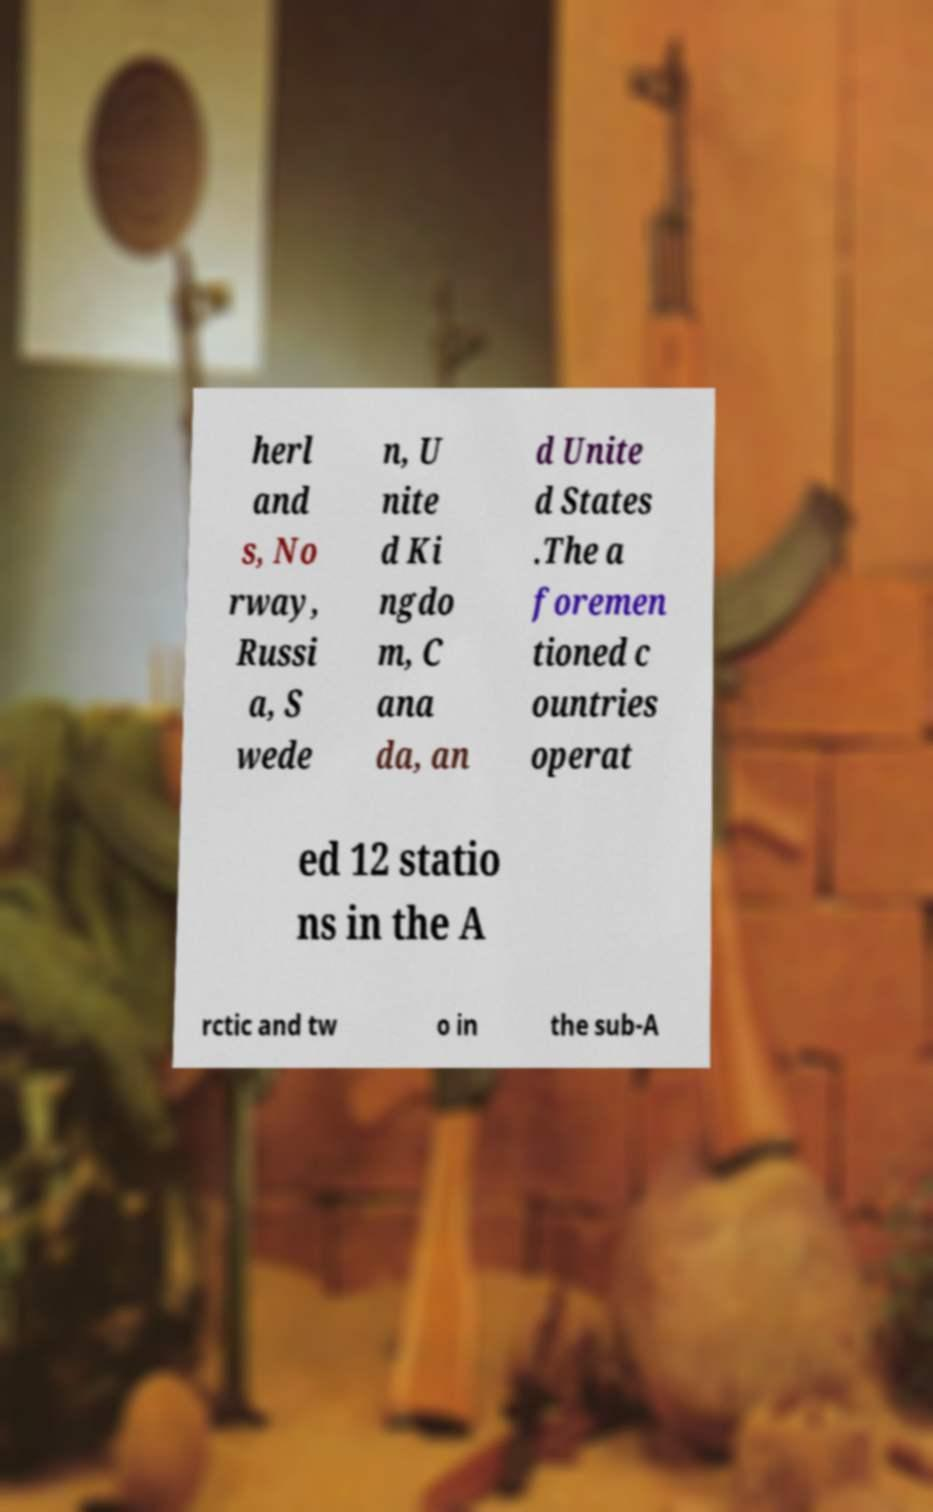Can you accurately transcribe the text from the provided image for me? herl and s, No rway, Russi a, S wede n, U nite d Ki ngdo m, C ana da, an d Unite d States .The a foremen tioned c ountries operat ed 12 statio ns in the A rctic and tw o in the sub-A 